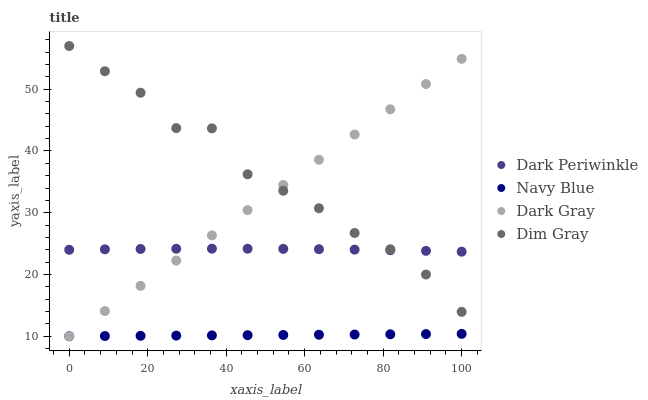Does Navy Blue have the minimum area under the curve?
Answer yes or no. Yes. Does Dim Gray have the maximum area under the curve?
Answer yes or no. Yes. Does Dim Gray have the minimum area under the curve?
Answer yes or no. No. Does Navy Blue have the maximum area under the curve?
Answer yes or no. No. Is Navy Blue the smoothest?
Answer yes or no. Yes. Is Dim Gray the roughest?
Answer yes or no. Yes. Is Dim Gray the smoothest?
Answer yes or no. No. Is Navy Blue the roughest?
Answer yes or no. No. Does Dark Gray have the lowest value?
Answer yes or no. Yes. Does Dim Gray have the lowest value?
Answer yes or no. No. Does Dim Gray have the highest value?
Answer yes or no. Yes. Does Navy Blue have the highest value?
Answer yes or no. No. Is Navy Blue less than Dim Gray?
Answer yes or no. Yes. Is Dim Gray greater than Navy Blue?
Answer yes or no. Yes. Does Dark Gray intersect Navy Blue?
Answer yes or no. Yes. Is Dark Gray less than Navy Blue?
Answer yes or no. No. Is Dark Gray greater than Navy Blue?
Answer yes or no. No. Does Navy Blue intersect Dim Gray?
Answer yes or no. No. 